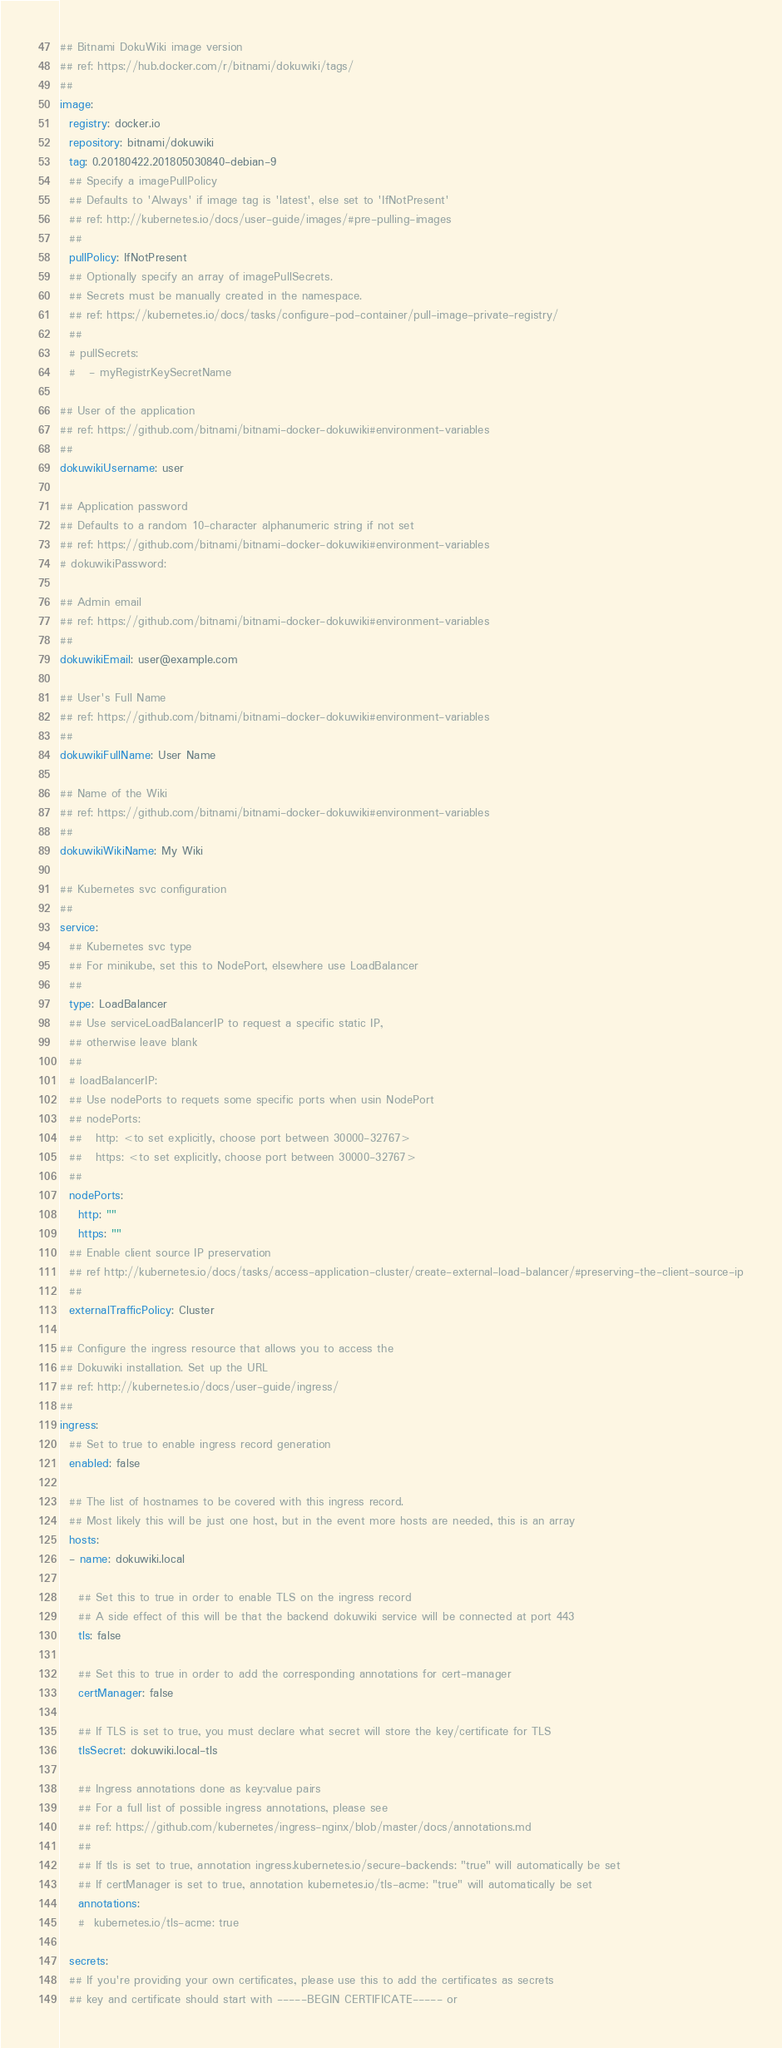<code> <loc_0><loc_0><loc_500><loc_500><_YAML_>## Bitnami DokuWiki image version
## ref: https://hub.docker.com/r/bitnami/dokuwiki/tags/
##
image:
  registry: docker.io
  repository: bitnami/dokuwiki
  tag: 0.20180422.201805030840-debian-9
  ## Specify a imagePullPolicy
  ## Defaults to 'Always' if image tag is 'latest', else set to 'IfNotPresent'
  ## ref: http://kubernetes.io/docs/user-guide/images/#pre-pulling-images
  ##
  pullPolicy: IfNotPresent
  ## Optionally specify an array of imagePullSecrets.
  ## Secrets must be manually created in the namespace.
  ## ref: https://kubernetes.io/docs/tasks/configure-pod-container/pull-image-private-registry/
  ##
  # pullSecrets:
  #   - myRegistrKeySecretName

## User of the application
## ref: https://github.com/bitnami/bitnami-docker-dokuwiki#environment-variables
##
dokuwikiUsername: user

## Application password
## Defaults to a random 10-character alphanumeric string if not set
## ref: https://github.com/bitnami/bitnami-docker-dokuwiki#environment-variables
# dokuwikiPassword:

## Admin email
## ref: https://github.com/bitnami/bitnami-docker-dokuwiki#environment-variables
##
dokuwikiEmail: user@example.com

## User's Full Name
## ref: https://github.com/bitnami/bitnami-docker-dokuwiki#environment-variables
##
dokuwikiFullName: User Name

## Name of the Wiki
## ref: https://github.com/bitnami/bitnami-docker-dokuwiki#environment-variables
##
dokuwikiWikiName: My Wiki

## Kubernetes svc configuration
##
service:
  ## Kubernetes svc type
  ## For minikube, set this to NodePort, elsewhere use LoadBalancer
  ##
  type: LoadBalancer
  ## Use serviceLoadBalancerIP to request a specific static IP,
  ## otherwise leave blank
  ##
  # loadBalancerIP:
  ## Use nodePorts to requets some specific ports when usin NodePort
  ## nodePorts:
  ##   http: <to set explicitly, choose port between 30000-32767>
  ##   https: <to set explicitly, choose port between 30000-32767>
  ##
  nodePorts:
    http: ""
    https: ""
  ## Enable client source IP preservation
  ## ref http://kubernetes.io/docs/tasks/access-application-cluster/create-external-load-balancer/#preserving-the-client-source-ip
  ##
  externalTrafficPolicy: Cluster

## Configure the ingress resource that allows you to access the
## Dokuwiki installation. Set up the URL
## ref: http://kubernetes.io/docs/user-guide/ingress/
##
ingress:
  ## Set to true to enable ingress record generation
  enabled: false

  ## The list of hostnames to be covered with this ingress record.
  ## Most likely this will be just one host, but in the event more hosts are needed, this is an array
  hosts:
  - name: dokuwiki.local

    ## Set this to true in order to enable TLS on the ingress record
    ## A side effect of this will be that the backend dokuwiki service will be connected at port 443
    tls: false

    ## Set this to true in order to add the corresponding annotations for cert-manager
    certManager: false

    ## If TLS is set to true, you must declare what secret will store the key/certificate for TLS
    tlsSecret: dokuwiki.local-tls

    ## Ingress annotations done as key:value pairs
    ## For a full list of possible ingress annotations, please see
    ## ref: https://github.com/kubernetes/ingress-nginx/blob/master/docs/annotations.md
    ##
    ## If tls is set to true, annotation ingress.kubernetes.io/secure-backends: "true" will automatically be set
    ## If certManager is set to true, annotation kubernetes.io/tls-acme: "true" will automatically be set
    annotations:
    #  kubernetes.io/tls-acme: true

  secrets:
  ## If you're providing your own certificates, please use this to add the certificates as secrets
  ## key and certificate should start with -----BEGIN CERTIFICATE----- or</code> 